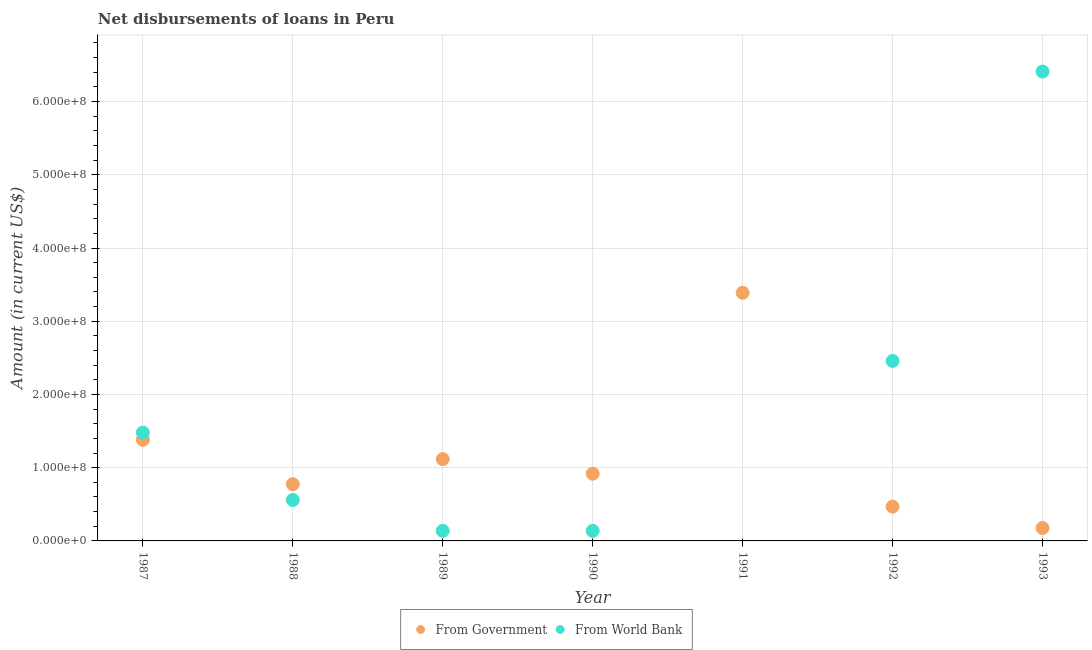How many different coloured dotlines are there?
Keep it short and to the point. 2. Is the number of dotlines equal to the number of legend labels?
Provide a succinct answer. No. What is the net disbursements of loan from world bank in 1989?
Provide a short and direct response. 1.38e+07. Across all years, what is the maximum net disbursements of loan from government?
Keep it short and to the point. 3.39e+08. Across all years, what is the minimum net disbursements of loan from government?
Keep it short and to the point. 1.76e+07. In which year was the net disbursements of loan from world bank maximum?
Ensure brevity in your answer.  1993. What is the total net disbursements of loan from world bank in the graph?
Keep it short and to the point. 1.12e+09. What is the difference between the net disbursements of loan from world bank in 1987 and that in 1992?
Your response must be concise. -9.79e+07. What is the difference between the net disbursements of loan from government in 1987 and the net disbursements of loan from world bank in 1988?
Give a very brief answer. 8.22e+07. What is the average net disbursements of loan from government per year?
Ensure brevity in your answer.  1.17e+08. In the year 1989, what is the difference between the net disbursements of loan from government and net disbursements of loan from world bank?
Offer a terse response. 9.79e+07. In how many years, is the net disbursements of loan from world bank greater than 320000000 US$?
Your response must be concise. 1. What is the ratio of the net disbursements of loan from world bank in 1989 to that in 1992?
Ensure brevity in your answer.  0.06. What is the difference between the highest and the second highest net disbursements of loan from world bank?
Keep it short and to the point. 3.95e+08. What is the difference between the highest and the lowest net disbursements of loan from government?
Ensure brevity in your answer.  3.21e+08. Is the net disbursements of loan from world bank strictly greater than the net disbursements of loan from government over the years?
Provide a succinct answer. No. Is the net disbursements of loan from government strictly less than the net disbursements of loan from world bank over the years?
Offer a terse response. No. How many dotlines are there?
Make the answer very short. 2. What is the difference between two consecutive major ticks on the Y-axis?
Provide a short and direct response. 1.00e+08. Are the values on the major ticks of Y-axis written in scientific E-notation?
Make the answer very short. Yes. Does the graph contain grids?
Offer a very short reply. Yes. Where does the legend appear in the graph?
Provide a short and direct response. Bottom center. How many legend labels are there?
Make the answer very short. 2. How are the legend labels stacked?
Offer a very short reply. Horizontal. What is the title of the graph?
Your answer should be compact. Net disbursements of loans in Peru. What is the label or title of the X-axis?
Make the answer very short. Year. What is the Amount (in current US$) in From Government in 1987?
Your answer should be very brief. 1.38e+08. What is the Amount (in current US$) in From World Bank in 1987?
Offer a terse response. 1.48e+08. What is the Amount (in current US$) of From Government in 1988?
Provide a short and direct response. 7.75e+07. What is the Amount (in current US$) of From World Bank in 1988?
Your response must be concise. 5.59e+07. What is the Amount (in current US$) of From Government in 1989?
Your answer should be compact. 1.12e+08. What is the Amount (in current US$) in From World Bank in 1989?
Make the answer very short. 1.38e+07. What is the Amount (in current US$) of From Government in 1990?
Provide a short and direct response. 9.18e+07. What is the Amount (in current US$) in From World Bank in 1990?
Provide a succinct answer. 1.38e+07. What is the Amount (in current US$) of From Government in 1991?
Your answer should be compact. 3.39e+08. What is the Amount (in current US$) of From World Bank in 1991?
Provide a short and direct response. 0. What is the Amount (in current US$) in From Government in 1992?
Offer a terse response. 4.68e+07. What is the Amount (in current US$) in From World Bank in 1992?
Keep it short and to the point. 2.46e+08. What is the Amount (in current US$) of From Government in 1993?
Make the answer very short. 1.76e+07. What is the Amount (in current US$) in From World Bank in 1993?
Your answer should be very brief. 6.41e+08. Across all years, what is the maximum Amount (in current US$) in From Government?
Offer a very short reply. 3.39e+08. Across all years, what is the maximum Amount (in current US$) in From World Bank?
Ensure brevity in your answer.  6.41e+08. Across all years, what is the minimum Amount (in current US$) in From Government?
Your response must be concise. 1.76e+07. What is the total Amount (in current US$) of From Government in the graph?
Give a very brief answer. 8.22e+08. What is the total Amount (in current US$) of From World Bank in the graph?
Make the answer very short. 1.12e+09. What is the difference between the Amount (in current US$) of From Government in 1987 and that in 1988?
Give a very brief answer. 6.06e+07. What is the difference between the Amount (in current US$) in From World Bank in 1987 and that in 1988?
Keep it short and to the point. 9.20e+07. What is the difference between the Amount (in current US$) in From Government in 1987 and that in 1989?
Ensure brevity in your answer.  2.64e+07. What is the difference between the Amount (in current US$) of From World Bank in 1987 and that in 1989?
Your response must be concise. 1.34e+08. What is the difference between the Amount (in current US$) of From Government in 1987 and that in 1990?
Ensure brevity in your answer.  4.63e+07. What is the difference between the Amount (in current US$) in From World Bank in 1987 and that in 1990?
Provide a succinct answer. 1.34e+08. What is the difference between the Amount (in current US$) of From Government in 1987 and that in 1991?
Your response must be concise. -2.01e+08. What is the difference between the Amount (in current US$) in From Government in 1987 and that in 1992?
Your answer should be compact. 9.13e+07. What is the difference between the Amount (in current US$) of From World Bank in 1987 and that in 1992?
Keep it short and to the point. -9.79e+07. What is the difference between the Amount (in current US$) of From Government in 1987 and that in 1993?
Provide a short and direct response. 1.20e+08. What is the difference between the Amount (in current US$) of From World Bank in 1987 and that in 1993?
Provide a short and direct response. -4.93e+08. What is the difference between the Amount (in current US$) of From Government in 1988 and that in 1989?
Offer a terse response. -3.43e+07. What is the difference between the Amount (in current US$) in From World Bank in 1988 and that in 1989?
Give a very brief answer. 4.21e+07. What is the difference between the Amount (in current US$) in From Government in 1988 and that in 1990?
Offer a very short reply. -1.43e+07. What is the difference between the Amount (in current US$) of From World Bank in 1988 and that in 1990?
Provide a succinct answer. 4.21e+07. What is the difference between the Amount (in current US$) in From Government in 1988 and that in 1991?
Keep it short and to the point. -2.61e+08. What is the difference between the Amount (in current US$) of From Government in 1988 and that in 1992?
Offer a very short reply. 3.07e+07. What is the difference between the Amount (in current US$) in From World Bank in 1988 and that in 1992?
Provide a short and direct response. -1.90e+08. What is the difference between the Amount (in current US$) in From Government in 1988 and that in 1993?
Keep it short and to the point. 5.98e+07. What is the difference between the Amount (in current US$) of From World Bank in 1988 and that in 1993?
Your answer should be compact. -5.85e+08. What is the difference between the Amount (in current US$) in From Government in 1989 and that in 1990?
Provide a succinct answer. 1.99e+07. What is the difference between the Amount (in current US$) in From World Bank in 1989 and that in 1990?
Offer a terse response. -3000. What is the difference between the Amount (in current US$) in From Government in 1989 and that in 1991?
Make the answer very short. -2.27e+08. What is the difference between the Amount (in current US$) in From Government in 1989 and that in 1992?
Make the answer very short. 6.49e+07. What is the difference between the Amount (in current US$) of From World Bank in 1989 and that in 1992?
Provide a succinct answer. -2.32e+08. What is the difference between the Amount (in current US$) in From Government in 1989 and that in 1993?
Provide a succinct answer. 9.41e+07. What is the difference between the Amount (in current US$) in From World Bank in 1989 and that in 1993?
Your answer should be compact. -6.27e+08. What is the difference between the Amount (in current US$) in From Government in 1990 and that in 1991?
Your answer should be compact. -2.47e+08. What is the difference between the Amount (in current US$) in From Government in 1990 and that in 1992?
Offer a very short reply. 4.50e+07. What is the difference between the Amount (in current US$) in From World Bank in 1990 and that in 1992?
Your response must be concise. -2.32e+08. What is the difference between the Amount (in current US$) of From Government in 1990 and that in 1993?
Your answer should be very brief. 7.42e+07. What is the difference between the Amount (in current US$) of From World Bank in 1990 and that in 1993?
Offer a terse response. -6.27e+08. What is the difference between the Amount (in current US$) of From Government in 1991 and that in 1992?
Offer a very short reply. 2.92e+08. What is the difference between the Amount (in current US$) of From Government in 1991 and that in 1993?
Make the answer very short. 3.21e+08. What is the difference between the Amount (in current US$) in From Government in 1992 and that in 1993?
Provide a succinct answer. 2.92e+07. What is the difference between the Amount (in current US$) in From World Bank in 1992 and that in 1993?
Make the answer very short. -3.95e+08. What is the difference between the Amount (in current US$) in From Government in 1987 and the Amount (in current US$) in From World Bank in 1988?
Offer a terse response. 8.22e+07. What is the difference between the Amount (in current US$) in From Government in 1987 and the Amount (in current US$) in From World Bank in 1989?
Give a very brief answer. 1.24e+08. What is the difference between the Amount (in current US$) in From Government in 1987 and the Amount (in current US$) in From World Bank in 1990?
Provide a succinct answer. 1.24e+08. What is the difference between the Amount (in current US$) in From Government in 1987 and the Amount (in current US$) in From World Bank in 1992?
Your answer should be very brief. -1.08e+08. What is the difference between the Amount (in current US$) in From Government in 1987 and the Amount (in current US$) in From World Bank in 1993?
Make the answer very short. -5.03e+08. What is the difference between the Amount (in current US$) of From Government in 1988 and the Amount (in current US$) of From World Bank in 1989?
Give a very brief answer. 6.37e+07. What is the difference between the Amount (in current US$) in From Government in 1988 and the Amount (in current US$) in From World Bank in 1990?
Give a very brief answer. 6.37e+07. What is the difference between the Amount (in current US$) in From Government in 1988 and the Amount (in current US$) in From World Bank in 1992?
Your answer should be compact. -1.68e+08. What is the difference between the Amount (in current US$) of From Government in 1988 and the Amount (in current US$) of From World Bank in 1993?
Offer a terse response. -5.64e+08. What is the difference between the Amount (in current US$) of From Government in 1989 and the Amount (in current US$) of From World Bank in 1990?
Provide a short and direct response. 9.79e+07. What is the difference between the Amount (in current US$) of From Government in 1989 and the Amount (in current US$) of From World Bank in 1992?
Provide a succinct answer. -1.34e+08. What is the difference between the Amount (in current US$) in From Government in 1989 and the Amount (in current US$) in From World Bank in 1993?
Provide a short and direct response. -5.29e+08. What is the difference between the Amount (in current US$) of From Government in 1990 and the Amount (in current US$) of From World Bank in 1992?
Your answer should be very brief. -1.54e+08. What is the difference between the Amount (in current US$) of From Government in 1990 and the Amount (in current US$) of From World Bank in 1993?
Keep it short and to the point. -5.49e+08. What is the difference between the Amount (in current US$) in From Government in 1991 and the Amount (in current US$) in From World Bank in 1992?
Provide a succinct answer. 9.31e+07. What is the difference between the Amount (in current US$) of From Government in 1991 and the Amount (in current US$) of From World Bank in 1993?
Make the answer very short. -3.02e+08. What is the difference between the Amount (in current US$) of From Government in 1992 and the Amount (in current US$) of From World Bank in 1993?
Offer a very short reply. -5.94e+08. What is the average Amount (in current US$) in From Government per year?
Ensure brevity in your answer.  1.17e+08. What is the average Amount (in current US$) of From World Bank per year?
Provide a short and direct response. 1.60e+08. In the year 1987, what is the difference between the Amount (in current US$) of From Government and Amount (in current US$) of From World Bank?
Ensure brevity in your answer.  -9.83e+06. In the year 1988, what is the difference between the Amount (in current US$) of From Government and Amount (in current US$) of From World Bank?
Offer a very short reply. 2.16e+07. In the year 1989, what is the difference between the Amount (in current US$) of From Government and Amount (in current US$) of From World Bank?
Keep it short and to the point. 9.79e+07. In the year 1990, what is the difference between the Amount (in current US$) of From Government and Amount (in current US$) of From World Bank?
Your response must be concise. 7.80e+07. In the year 1992, what is the difference between the Amount (in current US$) of From Government and Amount (in current US$) of From World Bank?
Your answer should be very brief. -1.99e+08. In the year 1993, what is the difference between the Amount (in current US$) in From Government and Amount (in current US$) in From World Bank?
Ensure brevity in your answer.  -6.23e+08. What is the ratio of the Amount (in current US$) in From Government in 1987 to that in 1988?
Ensure brevity in your answer.  1.78. What is the ratio of the Amount (in current US$) of From World Bank in 1987 to that in 1988?
Your answer should be very brief. 2.65. What is the ratio of the Amount (in current US$) in From Government in 1987 to that in 1989?
Ensure brevity in your answer.  1.24. What is the ratio of the Amount (in current US$) in From World Bank in 1987 to that in 1989?
Offer a very short reply. 10.73. What is the ratio of the Amount (in current US$) in From Government in 1987 to that in 1990?
Offer a very short reply. 1.5. What is the ratio of the Amount (in current US$) of From World Bank in 1987 to that in 1990?
Make the answer very short. 10.73. What is the ratio of the Amount (in current US$) of From Government in 1987 to that in 1991?
Your answer should be very brief. 0.41. What is the ratio of the Amount (in current US$) of From Government in 1987 to that in 1992?
Keep it short and to the point. 2.95. What is the ratio of the Amount (in current US$) of From World Bank in 1987 to that in 1992?
Keep it short and to the point. 0.6. What is the ratio of the Amount (in current US$) of From Government in 1987 to that in 1993?
Offer a terse response. 7.84. What is the ratio of the Amount (in current US$) of From World Bank in 1987 to that in 1993?
Keep it short and to the point. 0.23. What is the ratio of the Amount (in current US$) in From Government in 1988 to that in 1989?
Offer a terse response. 0.69. What is the ratio of the Amount (in current US$) of From World Bank in 1988 to that in 1989?
Offer a very short reply. 4.06. What is the ratio of the Amount (in current US$) of From Government in 1988 to that in 1990?
Offer a very short reply. 0.84. What is the ratio of the Amount (in current US$) of From World Bank in 1988 to that in 1990?
Make the answer very short. 4.06. What is the ratio of the Amount (in current US$) in From Government in 1988 to that in 1991?
Ensure brevity in your answer.  0.23. What is the ratio of the Amount (in current US$) in From Government in 1988 to that in 1992?
Your answer should be very brief. 1.66. What is the ratio of the Amount (in current US$) in From World Bank in 1988 to that in 1992?
Give a very brief answer. 0.23. What is the ratio of the Amount (in current US$) in From Government in 1988 to that in 1993?
Offer a very short reply. 4.4. What is the ratio of the Amount (in current US$) in From World Bank in 1988 to that in 1993?
Offer a terse response. 0.09. What is the ratio of the Amount (in current US$) of From Government in 1989 to that in 1990?
Your response must be concise. 1.22. What is the ratio of the Amount (in current US$) in From Government in 1989 to that in 1991?
Your answer should be compact. 0.33. What is the ratio of the Amount (in current US$) of From Government in 1989 to that in 1992?
Offer a terse response. 2.39. What is the ratio of the Amount (in current US$) in From World Bank in 1989 to that in 1992?
Offer a terse response. 0.06. What is the ratio of the Amount (in current US$) of From Government in 1989 to that in 1993?
Your answer should be very brief. 6.34. What is the ratio of the Amount (in current US$) of From World Bank in 1989 to that in 1993?
Give a very brief answer. 0.02. What is the ratio of the Amount (in current US$) in From Government in 1990 to that in 1991?
Your answer should be very brief. 0.27. What is the ratio of the Amount (in current US$) of From Government in 1990 to that in 1992?
Provide a succinct answer. 1.96. What is the ratio of the Amount (in current US$) in From World Bank in 1990 to that in 1992?
Your answer should be compact. 0.06. What is the ratio of the Amount (in current US$) in From Government in 1990 to that in 1993?
Ensure brevity in your answer.  5.21. What is the ratio of the Amount (in current US$) of From World Bank in 1990 to that in 1993?
Give a very brief answer. 0.02. What is the ratio of the Amount (in current US$) of From Government in 1991 to that in 1992?
Your response must be concise. 7.24. What is the ratio of the Amount (in current US$) of From Government in 1991 to that in 1993?
Give a very brief answer. 19.23. What is the ratio of the Amount (in current US$) in From Government in 1992 to that in 1993?
Provide a short and direct response. 2.66. What is the ratio of the Amount (in current US$) in From World Bank in 1992 to that in 1993?
Your response must be concise. 0.38. What is the difference between the highest and the second highest Amount (in current US$) in From Government?
Ensure brevity in your answer.  2.01e+08. What is the difference between the highest and the second highest Amount (in current US$) of From World Bank?
Ensure brevity in your answer.  3.95e+08. What is the difference between the highest and the lowest Amount (in current US$) in From Government?
Your response must be concise. 3.21e+08. What is the difference between the highest and the lowest Amount (in current US$) in From World Bank?
Provide a short and direct response. 6.41e+08. 